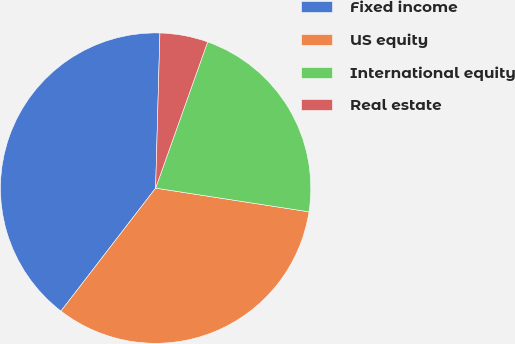Convert chart to OTSL. <chart><loc_0><loc_0><loc_500><loc_500><pie_chart><fcel>Fixed income<fcel>US equity<fcel>International equity<fcel>Real estate<nl><fcel>40.0%<fcel>33.0%<fcel>22.0%<fcel>5.0%<nl></chart> 